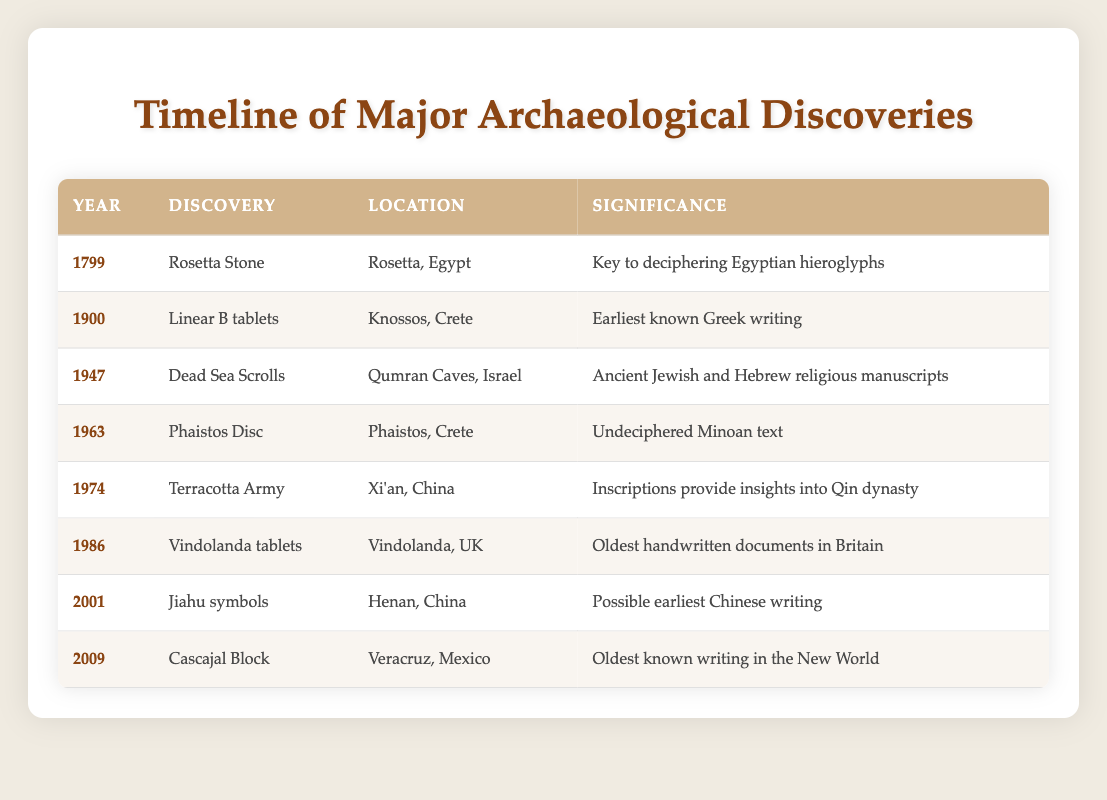What was discovered in 1947? According to the table, the discovery made in 1947 is the Dead Sea Scrolls.
Answer: Dead Sea Scrolls How many discoveries are listed from the 20th century? There are 6 discoveries from the 20th century as indicated by the years 1900, 1947, 1963, 1974, 1986, and 2001 listed in the table.
Answer: 6 Is the Rosetta Stone related to ancient Egyptian writing? Yes, the Rosetta Stone is significant as it is key to deciphering Egyptian hieroglyphs, which is an ancient Egyptian writing system.
Answer: Yes Which discovery has the earliest date listed? The earliest date listed in the table is 1799, which corresponds to the discovery of the Rosetta Stone.
Answer: Rosetta Stone Which two discoveries are located in Crete, and what years were they discovered? The two discoveries located in Crete are the Linear B tablets in 1900 and the Phaistos Disc in 1963, as stated in the rows for those discoveries.
Answer: Linear B tablets (1900) and Phaistos Disc (1963) What is the significance of the Cascajal Block? The Cascajal Block is significant because it is recognized as the oldest known writing in the New World. This information is found in the corresponding row for that discovery.
Answer: Oldest known writing in the New World Which discovery provides insights into the Qin dynasty? The discovery providing insights into the Qin dynasty is the Terracotta Army, noted for its inscriptions in the table.
Answer: Terracotta Army If you consider the years provided in the table, what is the difference between the earliest and latest discovery years? The earliest year mentioned is 1799 (Rosetta Stone), and the latest year is 2009 (Cascajal Block). To find the difference, subtract 1799 from 2009 which equals 210 years.
Answer: 210 years How many discoveries are there from locations outside of Europe? According to the table, the discoveries from locations outside of Europe are: the Rosetta Stone (Egypt), Dead Sea Scrolls (Israel), Terracotta Army (China), Jiahu symbols (China), and Cascajal Block (Mexico). This totals to 5 discoveries.
Answer: 5 